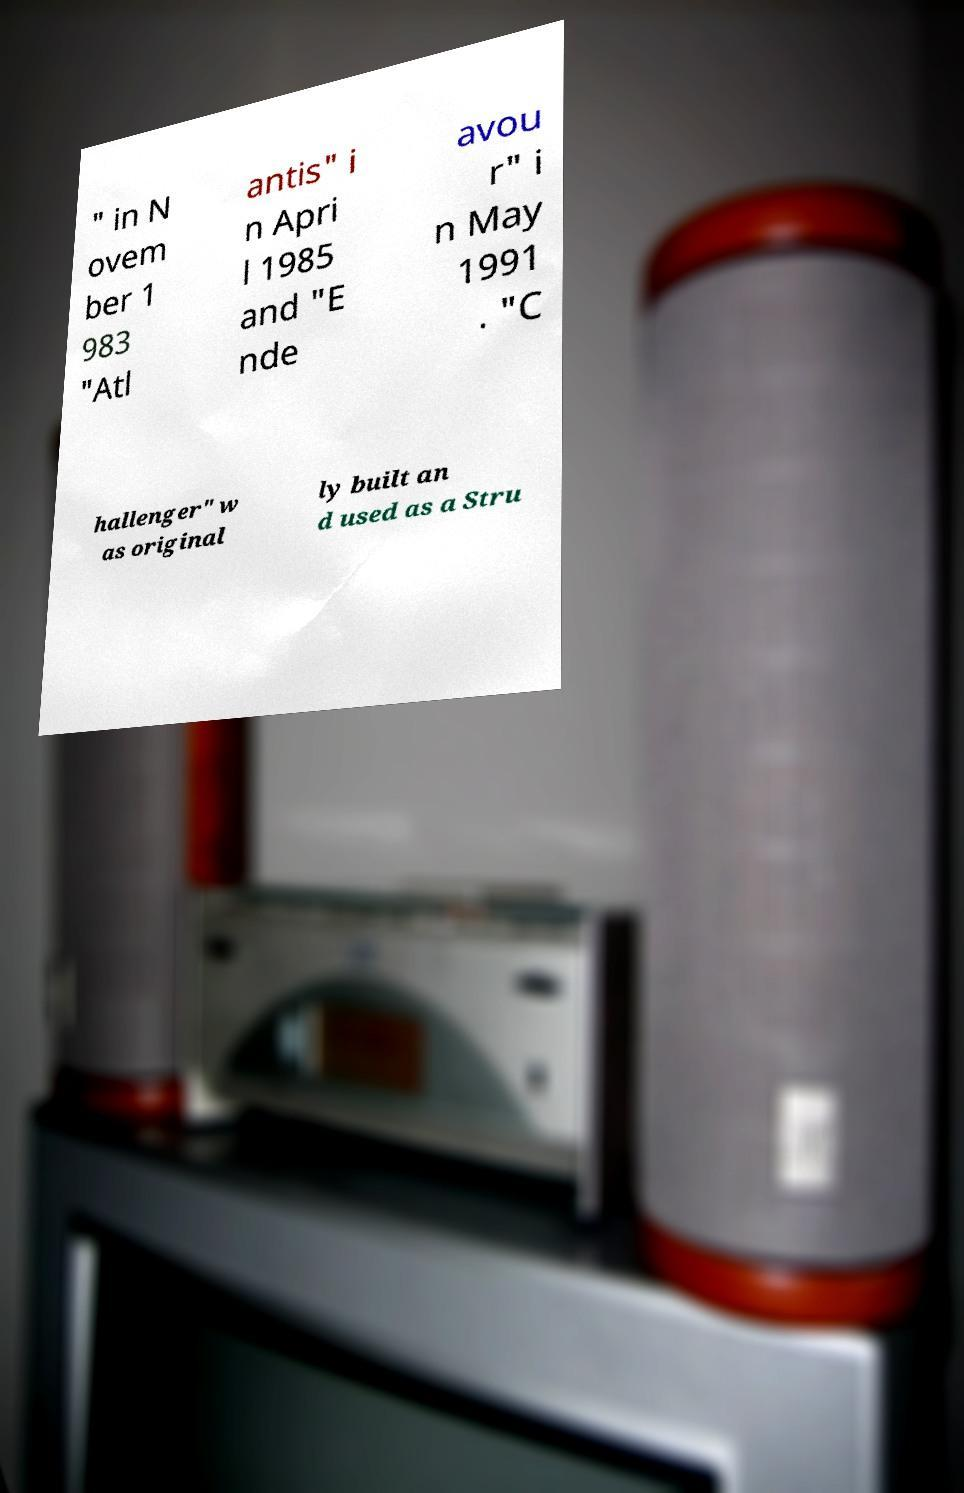Could you assist in decoding the text presented in this image and type it out clearly? " in N ovem ber 1 983 "Atl antis" i n Apri l 1985 and "E nde avou r" i n May 1991 . "C hallenger" w as original ly built an d used as a Stru 